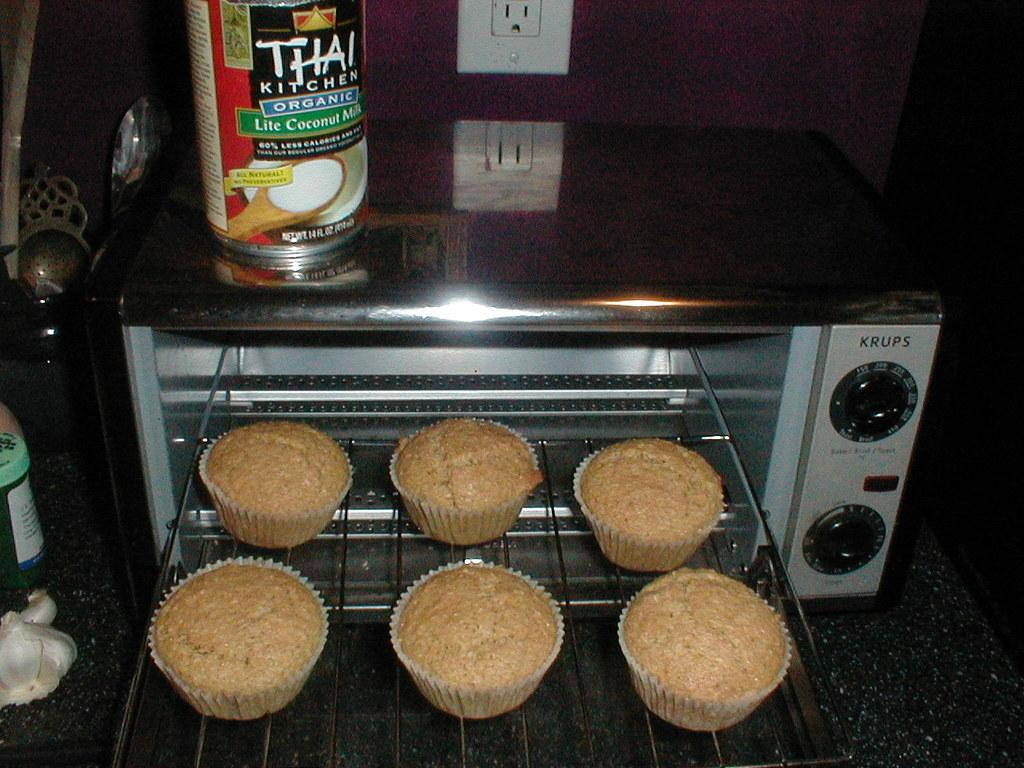<image>
Describe the image concisely. The six muffins were made in a Krups brand toaster oven. 